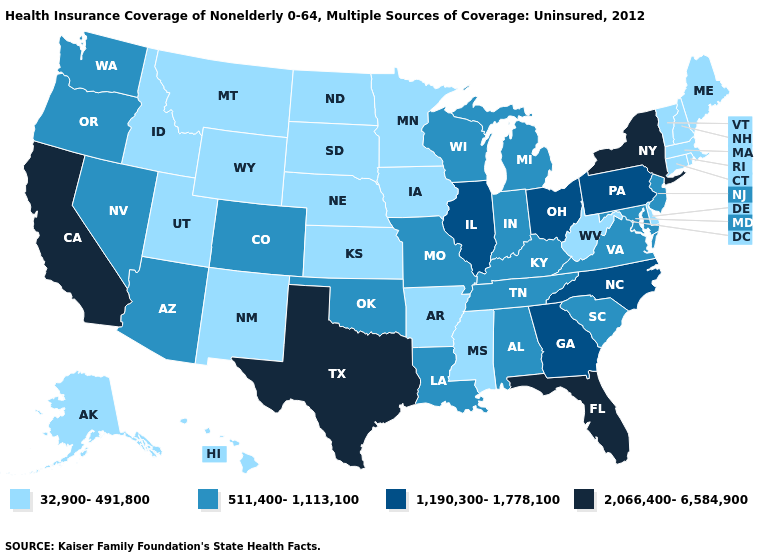What is the lowest value in states that border Kansas?
Be succinct. 32,900-491,800. Among the states that border Iowa , which have the highest value?
Write a very short answer. Illinois. What is the value of Arkansas?
Short answer required. 32,900-491,800. What is the value of Wyoming?
Give a very brief answer. 32,900-491,800. Name the states that have a value in the range 1,190,300-1,778,100?
Keep it brief. Georgia, Illinois, North Carolina, Ohio, Pennsylvania. What is the value of Delaware?
Write a very short answer. 32,900-491,800. What is the value of Maryland?
Answer briefly. 511,400-1,113,100. Which states have the lowest value in the USA?
Give a very brief answer. Alaska, Arkansas, Connecticut, Delaware, Hawaii, Idaho, Iowa, Kansas, Maine, Massachusetts, Minnesota, Mississippi, Montana, Nebraska, New Hampshire, New Mexico, North Dakota, Rhode Island, South Dakota, Utah, Vermont, West Virginia, Wyoming. Name the states that have a value in the range 32,900-491,800?
Keep it brief. Alaska, Arkansas, Connecticut, Delaware, Hawaii, Idaho, Iowa, Kansas, Maine, Massachusetts, Minnesota, Mississippi, Montana, Nebraska, New Hampshire, New Mexico, North Dakota, Rhode Island, South Dakota, Utah, Vermont, West Virginia, Wyoming. Does the first symbol in the legend represent the smallest category?
Concise answer only. Yes. Name the states that have a value in the range 511,400-1,113,100?
Short answer required. Alabama, Arizona, Colorado, Indiana, Kentucky, Louisiana, Maryland, Michigan, Missouri, Nevada, New Jersey, Oklahoma, Oregon, South Carolina, Tennessee, Virginia, Washington, Wisconsin. What is the value of New Jersey?
Concise answer only. 511,400-1,113,100. What is the value of Washington?
Give a very brief answer. 511,400-1,113,100. Does Washington have a higher value than Iowa?
Give a very brief answer. Yes. Which states have the lowest value in the USA?
Answer briefly. Alaska, Arkansas, Connecticut, Delaware, Hawaii, Idaho, Iowa, Kansas, Maine, Massachusetts, Minnesota, Mississippi, Montana, Nebraska, New Hampshire, New Mexico, North Dakota, Rhode Island, South Dakota, Utah, Vermont, West Virginia, Wyoming. 